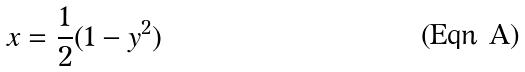Convert formula to latex. <formula><loc_0><loc_0><loc_500><loc_500>x = \frac { 1 } { 2 } ( 1 - y ^ { 2 } )</formula> 